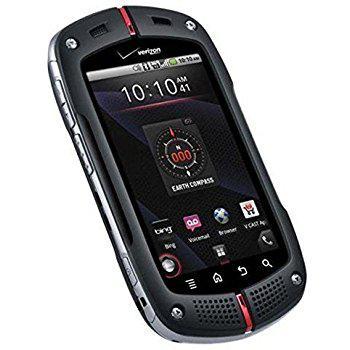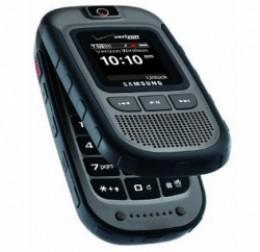The first image is the image on the left, the second image is the image on the right. Examine the images to the left and right. Is the description "Each image contains a single phone, and the phone in the right image has its top at least partially flipped open." accurate? Answer yes or no. Yes. 